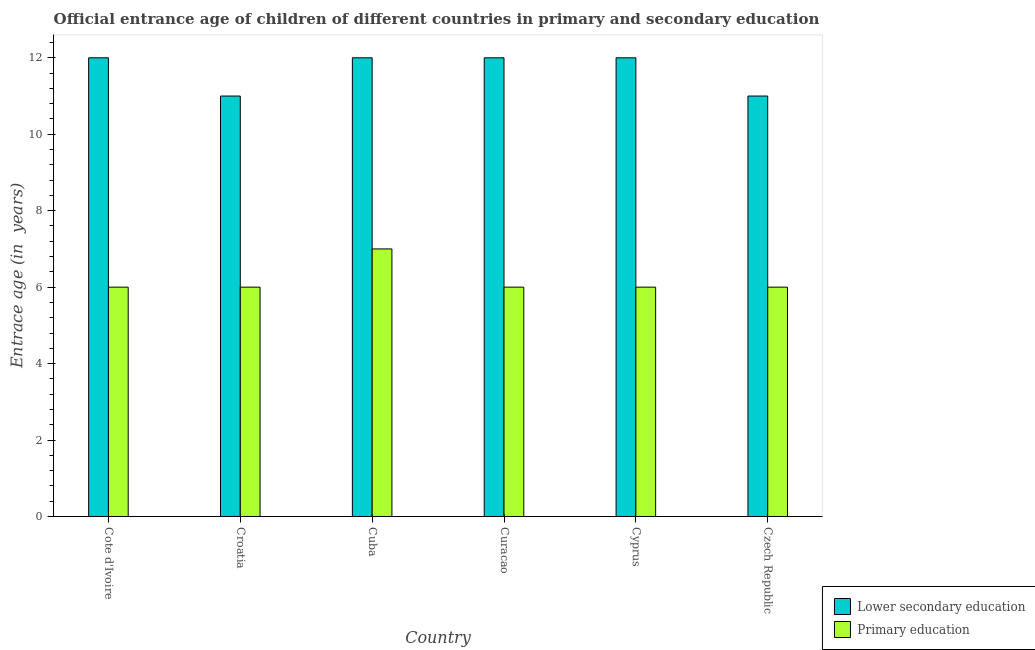How many bars are there on the 1st tick from the left?
Keep it short and to the point. 2. What is the label of the 6th group of bars from the left?
Provide a short and direct response. Czech Republic. In how many cases, is the number of bars for a given country not equal to the number of legend labels?
Your answer should be very brief. 0. What is the entrance age of children in lower secondary education in Cuba?
Offer a terse response. 12. Across all countries, what is the maximum entrance age of children in lower secondary education?
Your answer should be very brief. 12. Across all countries, what is the minimum entrance age of children in lower secondary education?
Give a very brief answer. 11. In which country was the entrance age of children in lower secondary education maximum?
Keep it short and to the point. Cote d'Ivoire. In which country was the entrance age of chiildren in primary education minimum?
Your answer should be very brief. Cote d'Ivoire. What is the total entrance age of children in lower secondary education in the graph?
Your response must be concise. 70. What is the difference between the entrance age of chiildren in primary education in Croatia and that in Cyprus?
Give a very brief answer. 0. What is the average entrance age of chiildren in primary education per country?
Offer a very short reply. 6.17. What is the difference between the entrance age of children in lower secondary education and entrance age of chiildren in primary education in Curacao?
Ensure brevity in your answer.  6. What is the difference between the highest and the lowest entrance age of chiildren in primary education?
Your answer should be compact. 1. What does the 1st bar from the left in Cote d'Ivoire represents?
Your response must be concise. Lower secondary education. What does the 1st bar from the right in Croatia represents?
Give a very brief answer. Primary education. How many bars are there?
Keep it short and to the point. 12. Are all the bars in the graph horizontal?
Offer a very short reply. No. How many countries are there in the graph?
Ensure brevity in your answer.  6. What is the difference between two consecutive major ticks on the Y-axis?
Your answer should be compact. 2. Does the graph contain grids?
Offer a terse response. No. How many legend labels are there?
Your answer should be very brief. 2. What is the title of the graph?
Offer a very short reply. Official entrance age of children of different countries in primary and secondary education. Does "Urban Population" appear as one of the legend labels in the graph?
Provide a succinct answer. No. What is the label or title of the X-axis?
Give a very brief answer. Country. What is the label or title of the Y-axis?
Provide a succinct answer. Entrace age (in  years). What is the Entrace age (in  years) of Primary education in Cuba?
Your answer should be very brief. 7. What is the Entrace age (in  years) of Lower secondary education in Curacao?
Offer a terse response. 12. What is the Entrace age (in  years) of Primary education in Czech Republic?
Ensure brevity in your answer.  6. Across all countries, what is the maximum Entrace age (in  years) in Lower secondary education?
Offer a terse response. 12. What is the total Entrace age (in  years) of Primary education in the graph?
Provide a succinct answer. 37. What is the difference between the Entrace age (in  years) of Lower secondary education in Cote d'Ivoire and that in Croatia?
Your answer should be very brief. 1. What is the difference between the Entrace age (in  years) in Lower secondary education in Cote d'Ivoire and that in Cuba?
Your answer should be very brief. 0. What is the difference between the Entrace age (in  years) in Primary education in Cote d'Ivoire and that in Cuba?
Your answer should be very brief. -1. What is the difference between the Entrace age (in  years) in Lower secondary education in Cote d'Ivoire and that in Cyprus?
Keep it short and to the point. 0. What is the difference between the Entrace age (in  years) in Lower secondary education in Croatia and that in Cuba?
Offer a very short reply. -1. What is the difference between the Entrace age (in  years) of Primary education in Croatia and that in Cuba?
Keep it short and to the point. -1. What is the difference between the Entrace age (in  years) of Lower secondary education in Croatia and that in Curacao?
Provide a succinct answer. -1. What is the difference between the Entrace age (in  years) in Primary education in Croatia and that in Cyprus?
Ensure brevity in your answer.  0. What is the difference between the Entrace age (in  years) in Lower secondary education in Croatia and that in Czech Republic?
Your response must be concise. 0. What is the difference between the Entrace age (in  years) in Primary education in Croatia and that in Czech Republic?
Offer a terse response. 0. What is the difference between the Entrace age (in  years) of Primary education in Cuba and that in Curacao?
Your answer should be compact. 1. What is the difference between the Entrace age (in  years) of Lower secondary education in Cuba and that in Cyprus?
Make the answer very short. 0. What is the difference between the Entrace age (in  years) of Lower secondary education in Cuba and that in Czech Republic?
Give a very brief answer. 1. What is the difference between the Entrace age (in  years) in Primary education in Curacao and that in Cyprus?
Offer a very short reply. 0. What is the difference between the Entrace age (in  years) in Lower secondary education in Curacao and that in Czech Republic?
Offer a terse response. 1. What is the difference between the Entrace age (in  years) of Primary education in Curacao and that in Czech Republic?
Give a very brief answer. 0. What is the difference between the Entrace age (in  years) in Primary education in Cyprus and that in Czech Republic?
Offer a very short reply. 0. What is the difference between the Entrace age (in  years) of Lower secondary education in Cote d'Ivoire and the Entrace age (in  years) of Primary education in Croatia?
Ensure brevity in your answer.  6. What is the difference between the Entrace age (in  years) in Lower secondary education in Cote d'Ivoire and the Entrace age (in  years) in Primary education in Czech Republic?
Your response must be concise. 6. What is the difference between the Entrace age (in  years) in Lower secondary education in Croatia and the Entrace age (in  years) in Primary education in Czech Republic?
Your answer should be very brief. 5. What is the difference between the Entrace age (in  years) in Lower secondary education in Cuba and the Entrace age (in  years) in Primary education in Cyprus?
Make the answer very short. 6. What is the difference between the Entrace age (in  years) in Lower secondary education in Curacao and the Entrace age (in  years) in Primary education in Cyprus?
Ensure brevity in your answer.  6. What is the difference between the Entrace age (in  years) in Lower secondary education in Curacao and the Entrace age (in  years) in Primary education in Czech Republic?
Provide a short and direct response. 6. What is the difference between the Entrace age (in  years) in Lower secondary education in Cyprus and the Entrace age (in  years) in Primary education in Czech Republic?
Your answer should be compact. 6. What is the average Entrace age (in  years) in Lower secondary education per country?
Your answer should be compact. 11.67. What is the average Entrace age (in  years) of Primary education per country?
Provide a succinct answer. 6.17. What is the difference between the Entrace age (in  years) in Lower secondary education and Entrace age (in  years) in Primary education in Cote d'Ivoire?
Your answer should be very brief. 6. What is the difference between the Entrace age (in  years) of Lower secondary education and Entrace age (in  years) of Primary education in Curacao?
Your response must be concise. 6. What is the difference between the Entrace age (in  years) in Lower secondary education and Entrace age (in  years) in Primary education in Cyprus?
Provide a succinct answer. 6. What is the ratio of the Entrace age (in  years) in Primary education in Cote d'Ivoire to that in Cuba?
Offer a terse response. 0.86. What is the ratio of the Entrace age (in  years) in Lower secondary education in Cote d'Ivoire to that in Curacao?
Your answer should be very brief. 1. What is the ratio of the Entrace age (in  years) of Primary education in Cote d'Ivoire to that in Curacao?
Offer a terse response. 1. What is the ratio of the Entrace age (in  years) in Primary education in Cote d'Ivoire to that in Cyprus?
Keep it short and to the point. 1. What is the ratio of the Entrace age (in  years) of Lower secondary education in Cote d'Ivoire to that in Czech Republic?
Ensure brevity in your answer.  1.09. What is the ratio of the Entrace age (in  years) of Primary education in Cote d'Ivoire to that in Czech Republic?
Provide a short and direct response. 1. What is the ratio of the Entrace age (in  years) of Primary education in Croatia to that in Cuba?
Offer a terse response. 0.86. What is the ratio of the Entrace age (in  years) in Primary education in Croatia to that in Curacao?
Your answer should be compact. 1. What is the ratio of the Entrace age (in  years) of Primary education in Croatia to that in Cyprus?
Offer a very short reply. 1. What is the ratio of the Entrace age (in  years) in Primary education in Croatia to that in Czech Republic?
Make the answer very short. 1. What is the ratio of the Entrace age (in  years) in Lower secondary education in Cuba to that in Curacao?
Your answer should be compact. 1. What is the ratio of the Entrace age (in  years) of Primary education in Cuba to that in Curacao?
Keep it short and to the point. 1.17. What is the ratio of the Entrace age (in  years) of Primary education in Cuba to that in Cyprus?
Offer a terse response. 1.17. What is the ratio of the Entrace age (in  years) in Lower secondary education in Cuba to that in Czech Republic?
Keep it short and to the point. 1.09. What is the ratio of the Entrace age (in  years) in Primary education in Cuba to that in Czech Republic?
Provide a short and direct response. 1.17. What is the ratio of the Entrace age (in  years) of Primary education in Curacao to that in Czech Republic?
Ensure brevity in your answer.  1. What is the ratio of the Entrace age (in  years) of Lower secondary education in Cyprus to that in Czech Republic?
Make the answer very short. 1.09. What is the difference between the highest and the second highest Entrace age (in  years) in Lower secondary education?
Provide a succinct answer. 0. What is the difference between the highest and the lowest Entrace age (in  years) in Lower secondary education?
Provide a short and direct response. 1. 